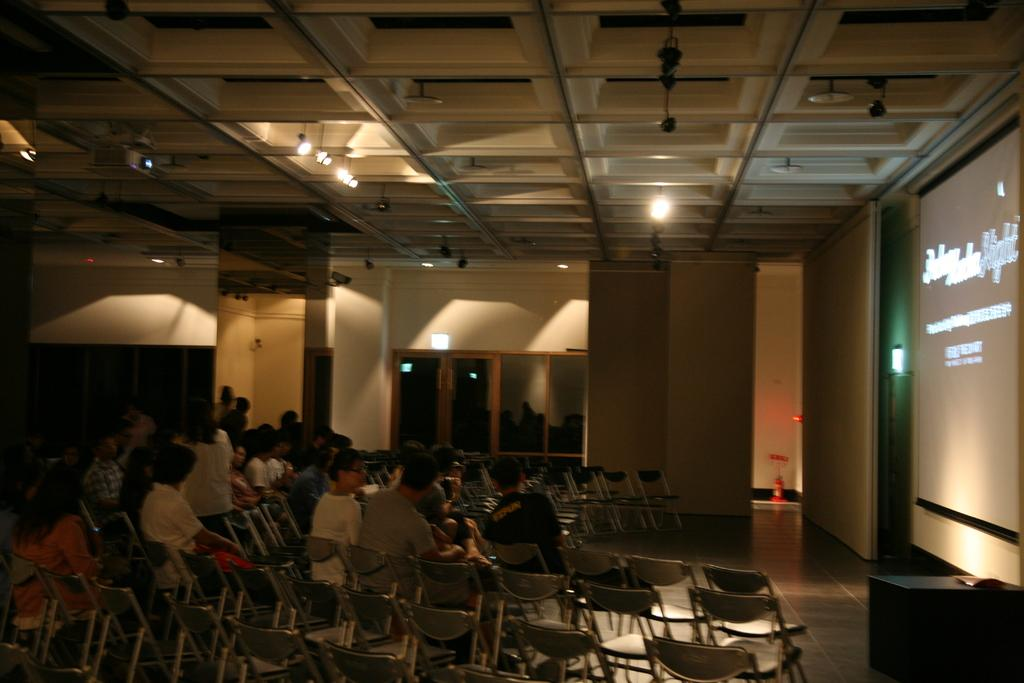How many people are in the image? There is a group of people in the image. What are the people doing in the image? The people are sitting on chairs. What is located behind the people in the image? The people are in front of a screen. What type of stove can be seen in the image? There is no stove present in the image. Are the people using quills to write on the screen in the image? There is no indication in the image that the people are using quills or writing on the screen. 